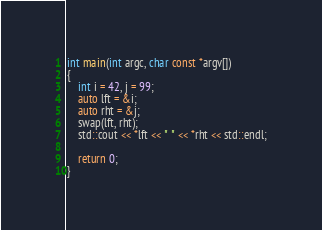Convert code to text. <code><loc_0><loc_0><loc_500><loc_500><_C++_>
int main(int argc, char const *argv[])
{
    int i = 42, j = 99;
    auto lft = &i;
    auto rht = &j;
    swap(lft, rht);
    std::cout << *lft << " " << *rht << std::endl;

    return 0;
}
</code> 